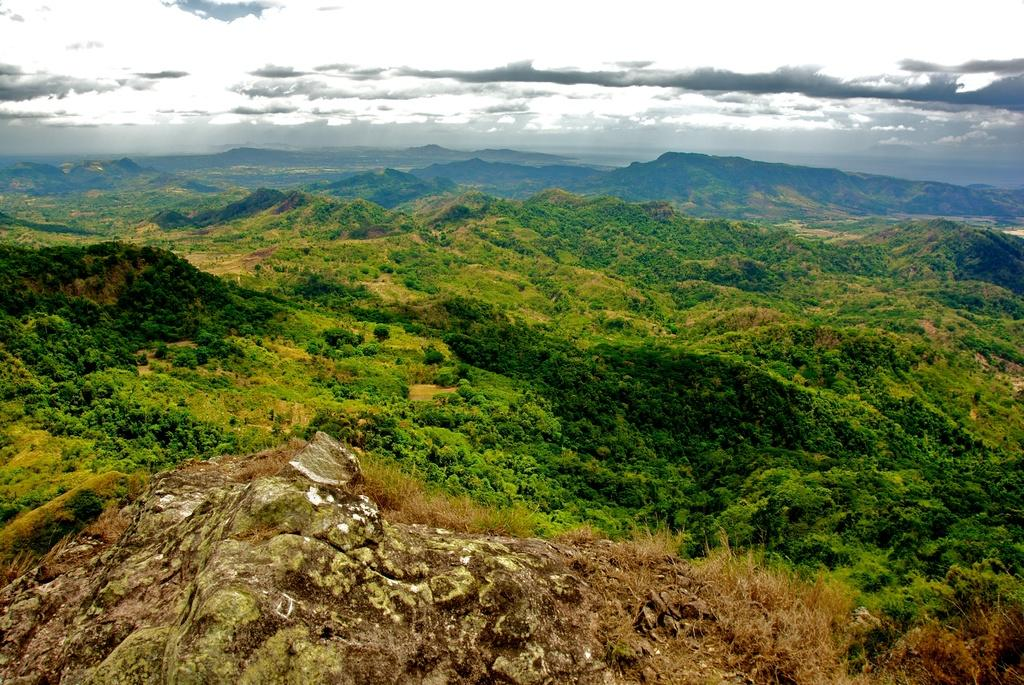What type of vegetation can be seen in the image? There are trees in the image. What type of geographical feature is present in the image? There are hills in the image. What is visible in the sky in the image? There are clouds in the sky. What type of farm equipment can be seen in the image? There is no farm equipment present in the image. 